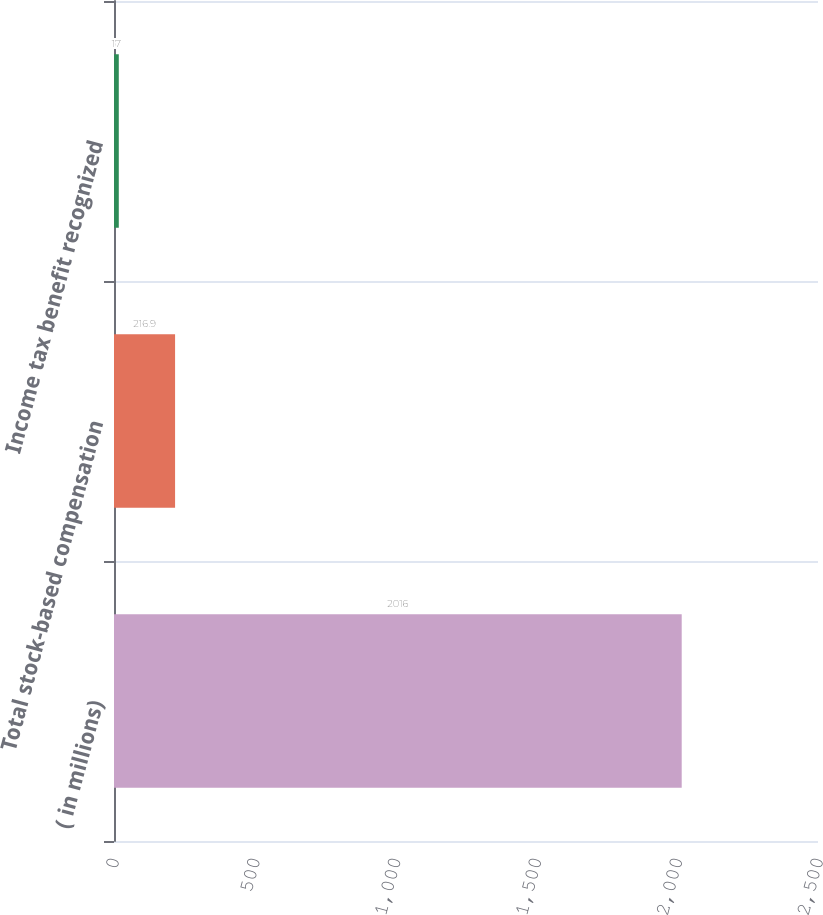Convert chart. <chart><loc_0><loc_0><loc_500><loc_500><bar_chart><fcel>( in millions)<fcel>Total stock-based compensation<fcel>Income tax benefit recognized<nl><fcel>2016<fcel>216.9<fcel>17<nl></chart> 